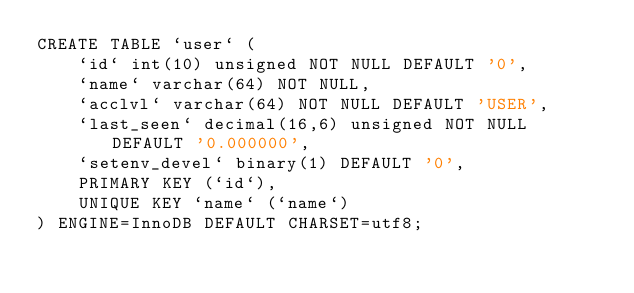<code> <loc_0><loc_0><loc_500><loc_500><_SQL_>CREATE TABLE `user` (
    `id` int(10) unsigned NOT NULL DEFAULT '0',
    `name` varchar(64) NOT NULL,
    `acclvl` varchar(64) NOT NULL DEFAULT 'USER',
    `last_seen` decimal(16,6) unsigned NOT NULL DEFAULT '0.000000',
    `setenv_devel` binary(1) DEFAULT '0',
    PRIMARY KEY (`id`),
    UNIQUE KEY `name` (`name`)
) ENGINE=InnoDB DEFAULT CHARSET=utf8;
</code> 